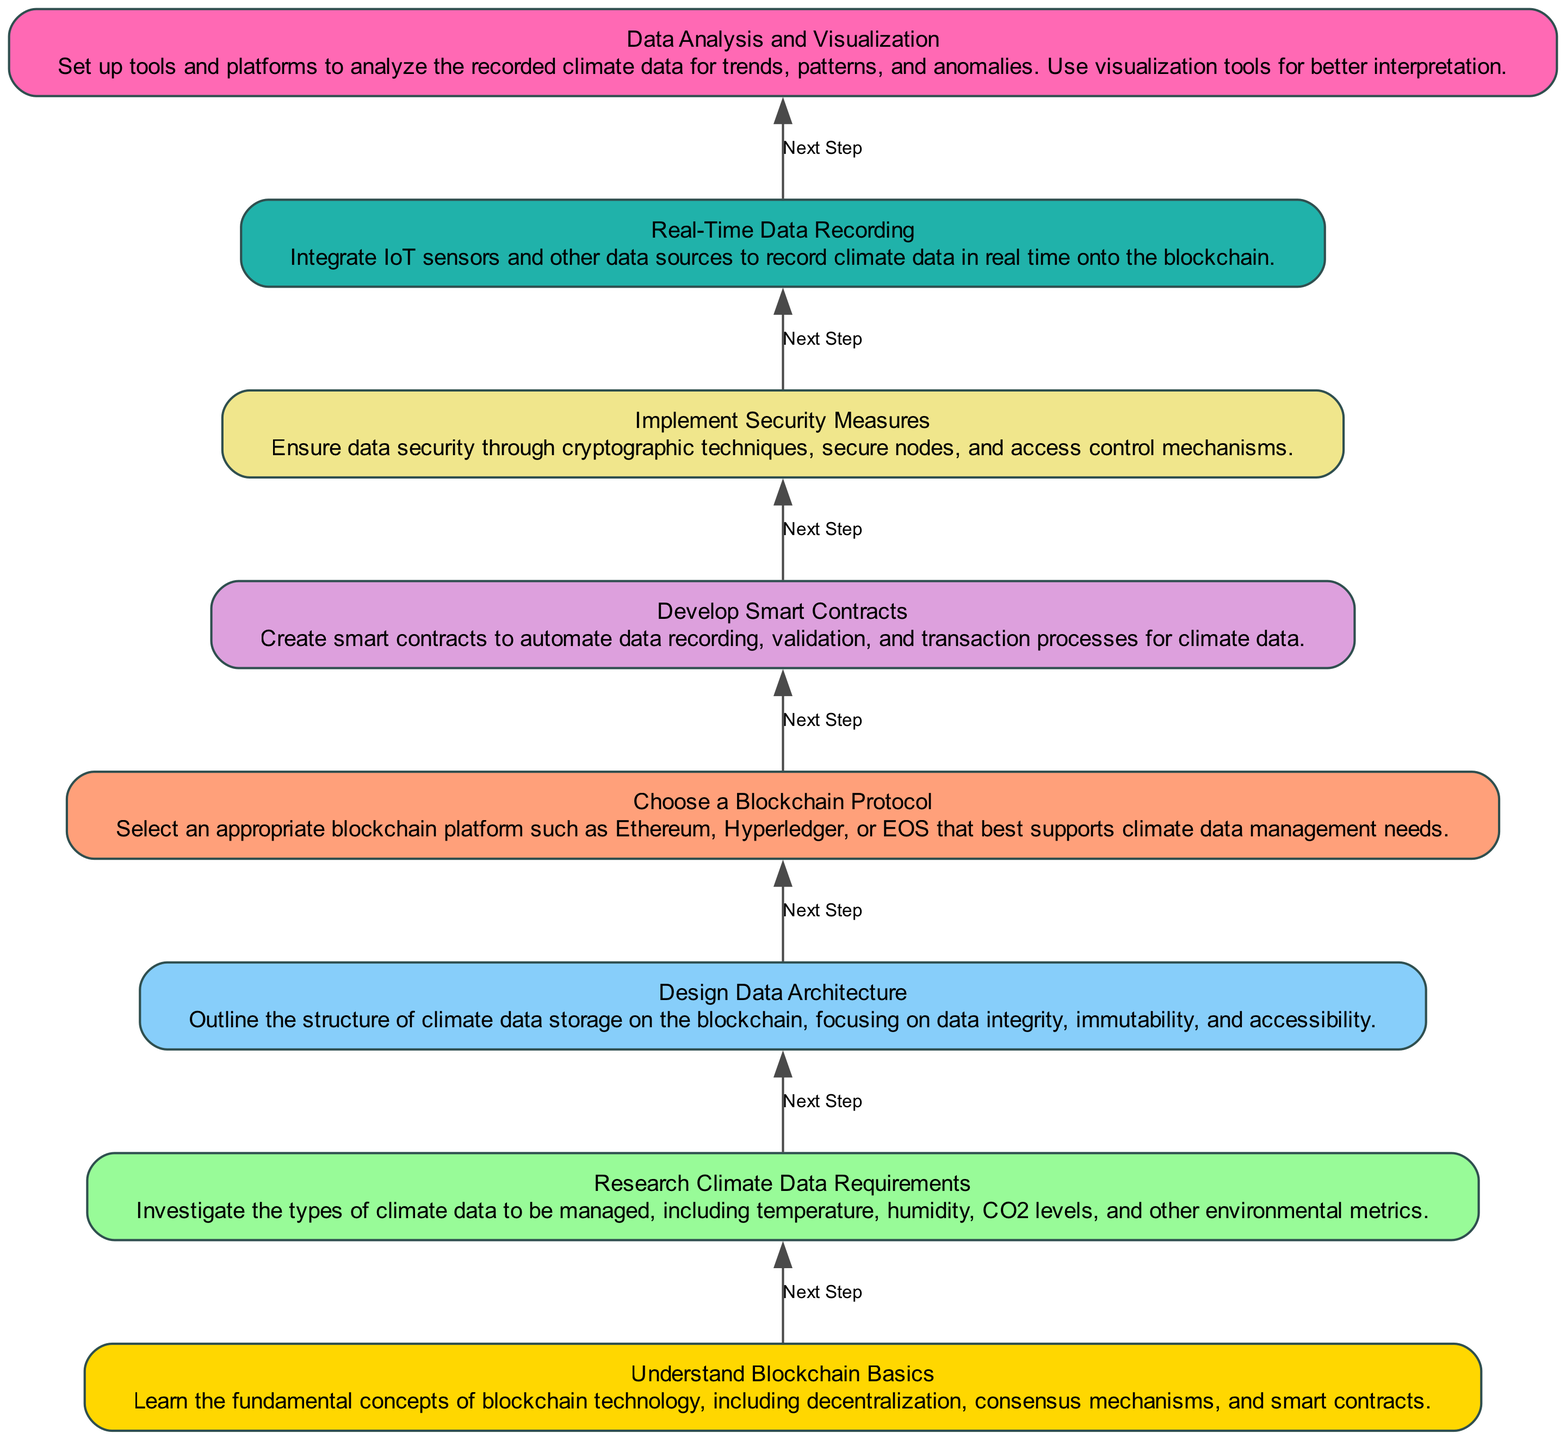What is the first step in the diagram? The diagram begins with "Understand Blockchain Basics," which is the first node and represents the initial step.
Answer: Understand Blockchain Basics How many steps are there in total? By counting the number of nodes in the diagram, there are a total of eight steps from the bottom to the top.
Answer: Eight What node follows "Implement Security Measures"? The next node after "Implement Security Measures" is "Real-Time Data Recording." This follows the flow of steps shown in the diagram.
Answer: Real-Time Data Recording Which step involves the selection of a blockchain platform? The step that involves selecting a blockchain platform is "Choose a Blockchain Protocol." It is critical for determining the framework for climate data management.
Answer: Choose a Blockchain Protocol What is the relationship between "Choose a Blockchain Protocol" and "Develop Smart Contracts"? "Choose a Blockchain Protocol" is a prerequisite step that leads directly to "Develop Smart Contracts," indicating that smart contracts depend on the chosen blockchain protocol.
Answer: Next Step What type of data is designed for recording in the "Design Data Architecture"? The "Design Data Architecture" step focuses on climate data, specifically on structuring its storage, which includes temperature, humidity, and CO2 levels, among others.
Answer: Climate data How is data recorded onto the blockchain according to the diagram? Data is recorded onto the blockchain through real-time integration of IoT sensors and data sources as indicated in the "Real-Time Data Recording" step.
Answer: IoT sensors What is the purpose of the "Data Analysis and Visualization" step? The purpose of "Data Analysis and Visualization" is to analyze recorded climate data for trends and patterns, making it essential for interpreting the data effectively.
Answer: Analyze climate data Which step comes immediately before "Data Analysis and Visualization"? The step that comes immediately before "Data Analysis and Visualization" is "Real-Time Data Recording," showing the flow of data into analysis.
Answer: Real-Time Data Recording 